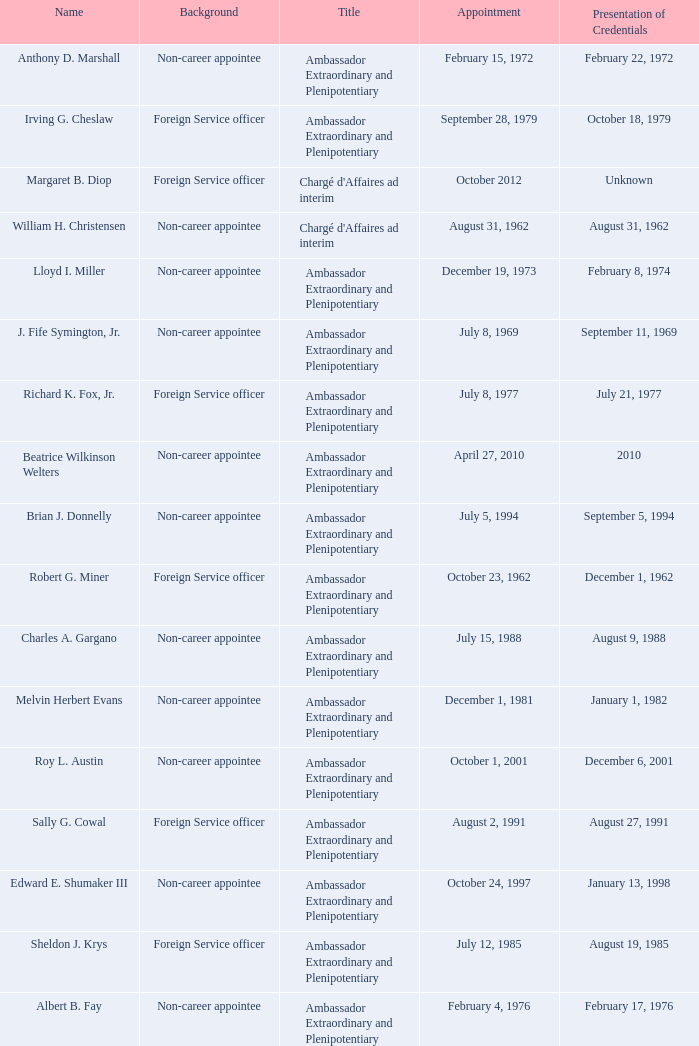What was Anthony D. Marshall's title? Ambassador Extraordinary and Plenipotentiary. 